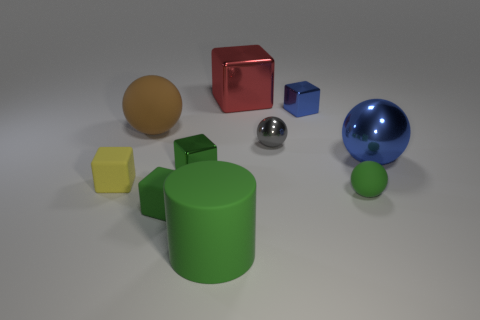Subtract all green cubes. How many were subtracted if there are1green cubes left? 1 Subtract all tiny blue shiny cubes. How many cubes are left? 4 Subtract all gray spheres. How many green blocks are left? 2 Subtract all red blocks. How many blocks are left? 4 Subtract 2 blocks. How many blocks are left? 3 Subtract all cylinders. How many objects are left? 9 Subtract all purple cubes. Subtract all blue balls. How many cubes are left? 5 Subtract 0 gray cylinders. How many objects are left? 10 Subtract all green matte objects. Subtract all tiny yellow objects. How many objects are left? 6 Add 5 large green objects. How many large green objects are left? 6 